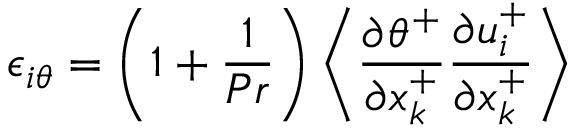<formula> <loc_0><loc_0><loc_500><loc_500>\epsilon _ { i \theta } = \left ( 1 + \frac { 1 } { P r } \right ) \left < \frac { \partial \theta ^ { + } } { \partial x _ { k } ^ { + } } \frac { \partial u _ { i } ^ { + } } { \partial x _ { k } ^ { + } } \right ></formula> 